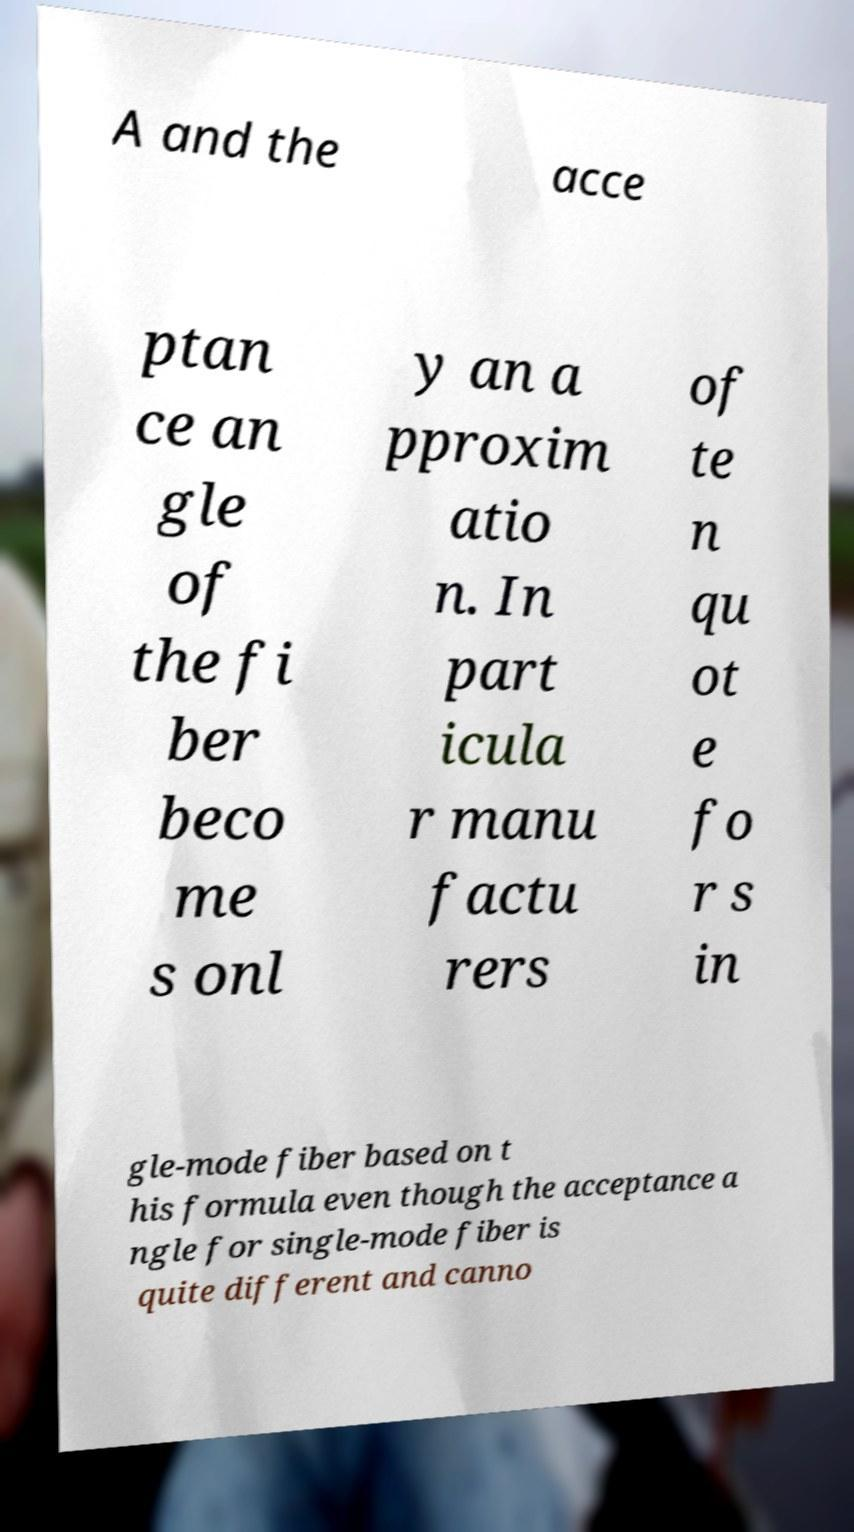There's text embedded in this image that I need extracted. Can you transcribe it verbatim? A and the acce ptan ce an gle of the fi ber beco me s onl y an a pproxim atio n. In part icula r manu factu rers of te n qu ot e fo r s in gle-mode fiber based on t his formula even though the acceptance a ngle for single-mode fiber is quite different and canno 